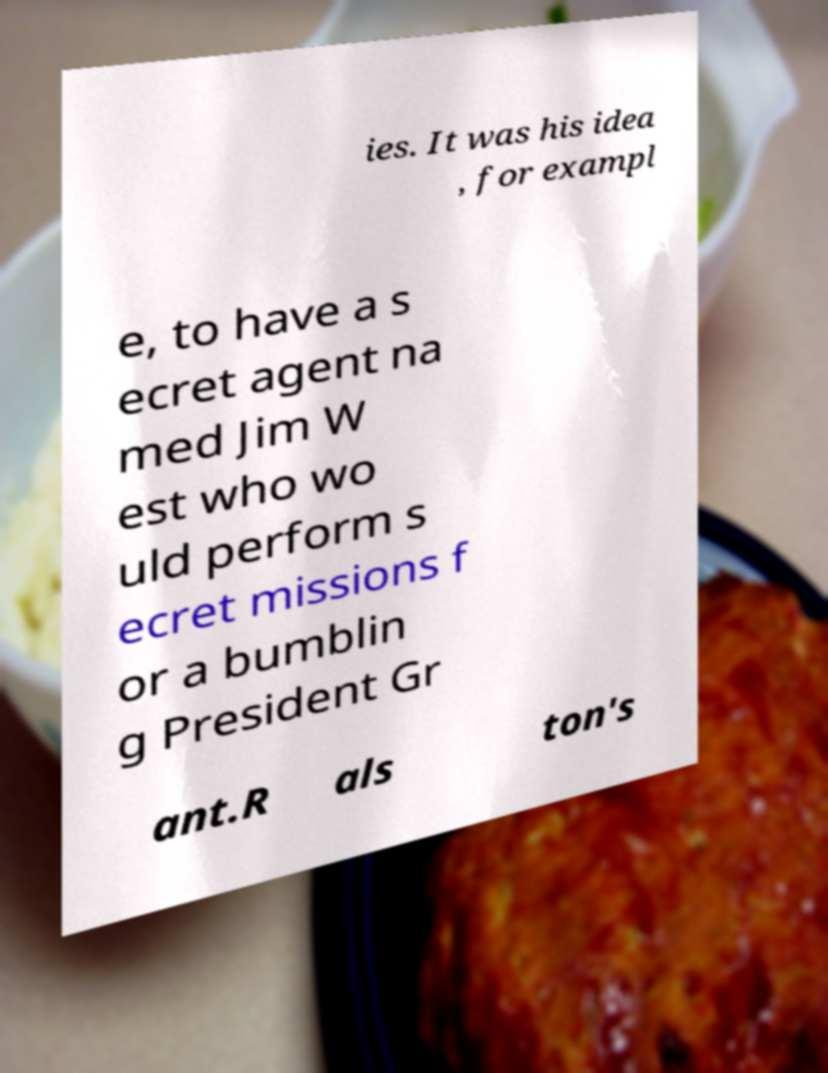Can you accurately transcribe the text from the provided image for me? ies. It was his idea , for exampl e, to have a s ecret agent na med Jim W est who wo uld perform s ecret missions f or a bumblin g President Gr ant.R als ton's 